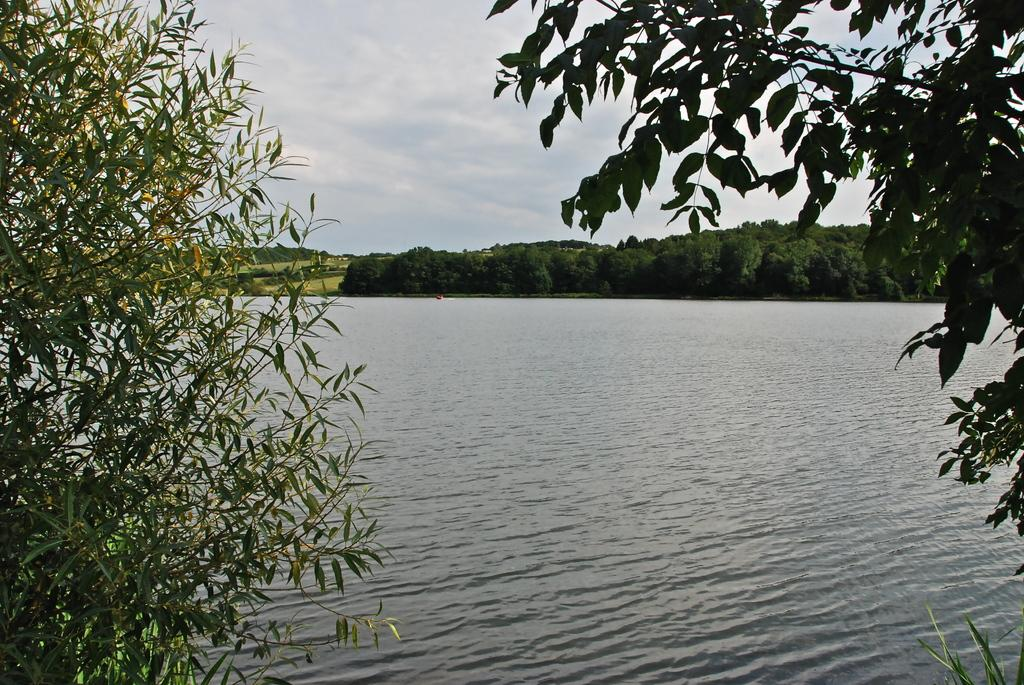What type of vegetation can be seen in the image? There are leaves and trees visible in the image. What natural element is present in the image? Water is visible in the image. How would you describe the sky in the image? The sky is cloudy in the image. What type of potato is being stretched in anger in the image? There is no potato present in the image, nor is there any indication of anger or stretching. 